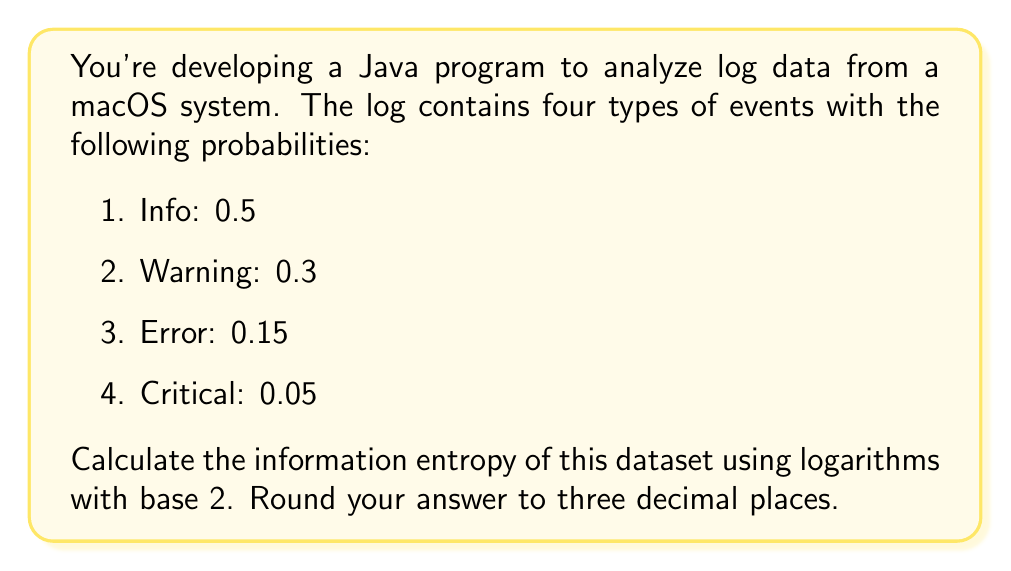Provide a solution to this math problem. To calculate the information entropy of a dataset, we use the formula:

$$H = -\sum_{i=1}^{n} p_i \log_2(p_i)$$

Where $H$ is the entropy, $p_i$ is the probability of each event, and $n$ is the number of different events.

Let's calculate for each event:

1. Info: $-0.5 \log_2(0.5)$
2. Warning: $-0.3 \log_2(0.3)$
3. Error: $-0.15 \log_2(0.15)$
4. Critical: $-0.05 \log_2(0.05)$

Now, let's compute each term:

1. $-0.5 \log_2(0.5) = 0.5$
2. $-0.3 \log_2(0.3) \approx 0.521$
3. $-0.15 \log_2(0.15) \approx 0.411$
4. $-0.05 \log_2(0.05) \approx 0.216$

Sum up all terms:

$$H = 0.5 + 0.521 + 0.411 + 0.216 = 1.648$$

Rounding to three decimal places:

$$H \approx 1.648$$

In Java, you could implement this calculation using the Math.log() function and converting to base 2:

```java
double entropy = 0;
double[] probabilities = {0.5, 0.3, 0.15, 0.05};
for (double p : probabilities) {
    entropy -= p * (Math.log(p) / Math.log(2));
}
System.out.printf("Entropy: %.3f", entropy);
```
Answer: 1.648 bits 